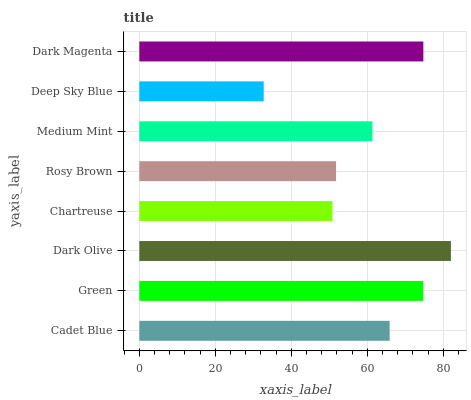Is Deep Sky Blue the minimum?
Answer yes or no. Yes. Is Dark Olive the maximum?
Answer yes or no. Yes. Is Green the minimum?
Answer yes or no. No. Is Green the maximum?
Answer yes or no. No. Is Green greater than Cadet Blue?
Answer yes or no. Yes. Is Cadet Blue less than Green?
Answer yes or no. Yes. Is Cadet Blue greater than Green?
Answer yes or no. No. Is Green less than Cadet Blue?
Answer yes or no. No. Is Cadet Blue the high median?
Answer yes or no. Yes. Is Medium Mint the low median?
Answer yes or no. Yes. Is Medium Mint the high median?
Answer yes or no. No. Is Rosy Brown the low median?
Answer yes or no. No. 